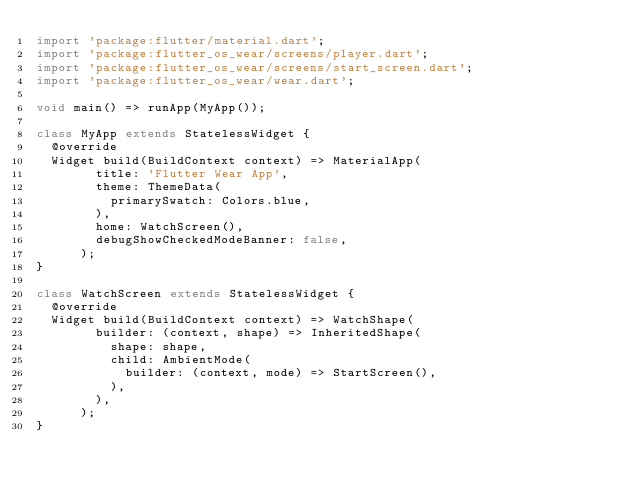Convert code to text. <code><loc_0><loc_0><loc_500><loc_500><_Dart_>import 'package:flutter/material.dart';
import 'package:flutter_os_wear/screens/player.dart';
import 'package:flutter_os_wear/screens/start_screen.dart';
import 'package:flutter_os_wear/wear.dart';

void main() => runApp(MyApp());

class MyApp extends StatelessWidget {
  @override
  Widget build(BuildContext context) => MaterialApp(
        title: 'Flutter Wear App',
        theme: ThemeData(
          primarySwatch: Colors.blue,
        ),
        home: WatchScreen(),
        debugShowCheckedModeBanner: false,
      );
}

class WatchScreen extends StatelessWidget {
  @override
  Widget build(BuildContext context) => WatchShape(
        builder: (context, shape) => InheritedShape(
          shape: shape,
          child: AmbientMode(
            builder: (context, mode) => StartScreen(),
          ),
        ),
      );
}
</code> 